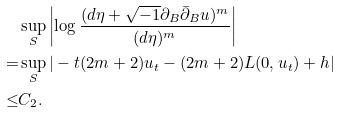Convert formula to latex. <formula><loc_0><loc_0><loc_500><loc_500>& \sup _ { S } \left | \log \frac { ( d \eta + \sqrt { - 1 } \partial _ { B } \bar { \partial } _ { B } u ) ^ { m } } { ( d \eta ) ^ { m } } \right | \\ = & \sup _ { S } | - t ( 2 m + 2 ) u _ { t } - ( 2 m + 2 ) L ( 0 , u _ { t } ) + h | \\ \leq & C _ { 2 } .</formula> 